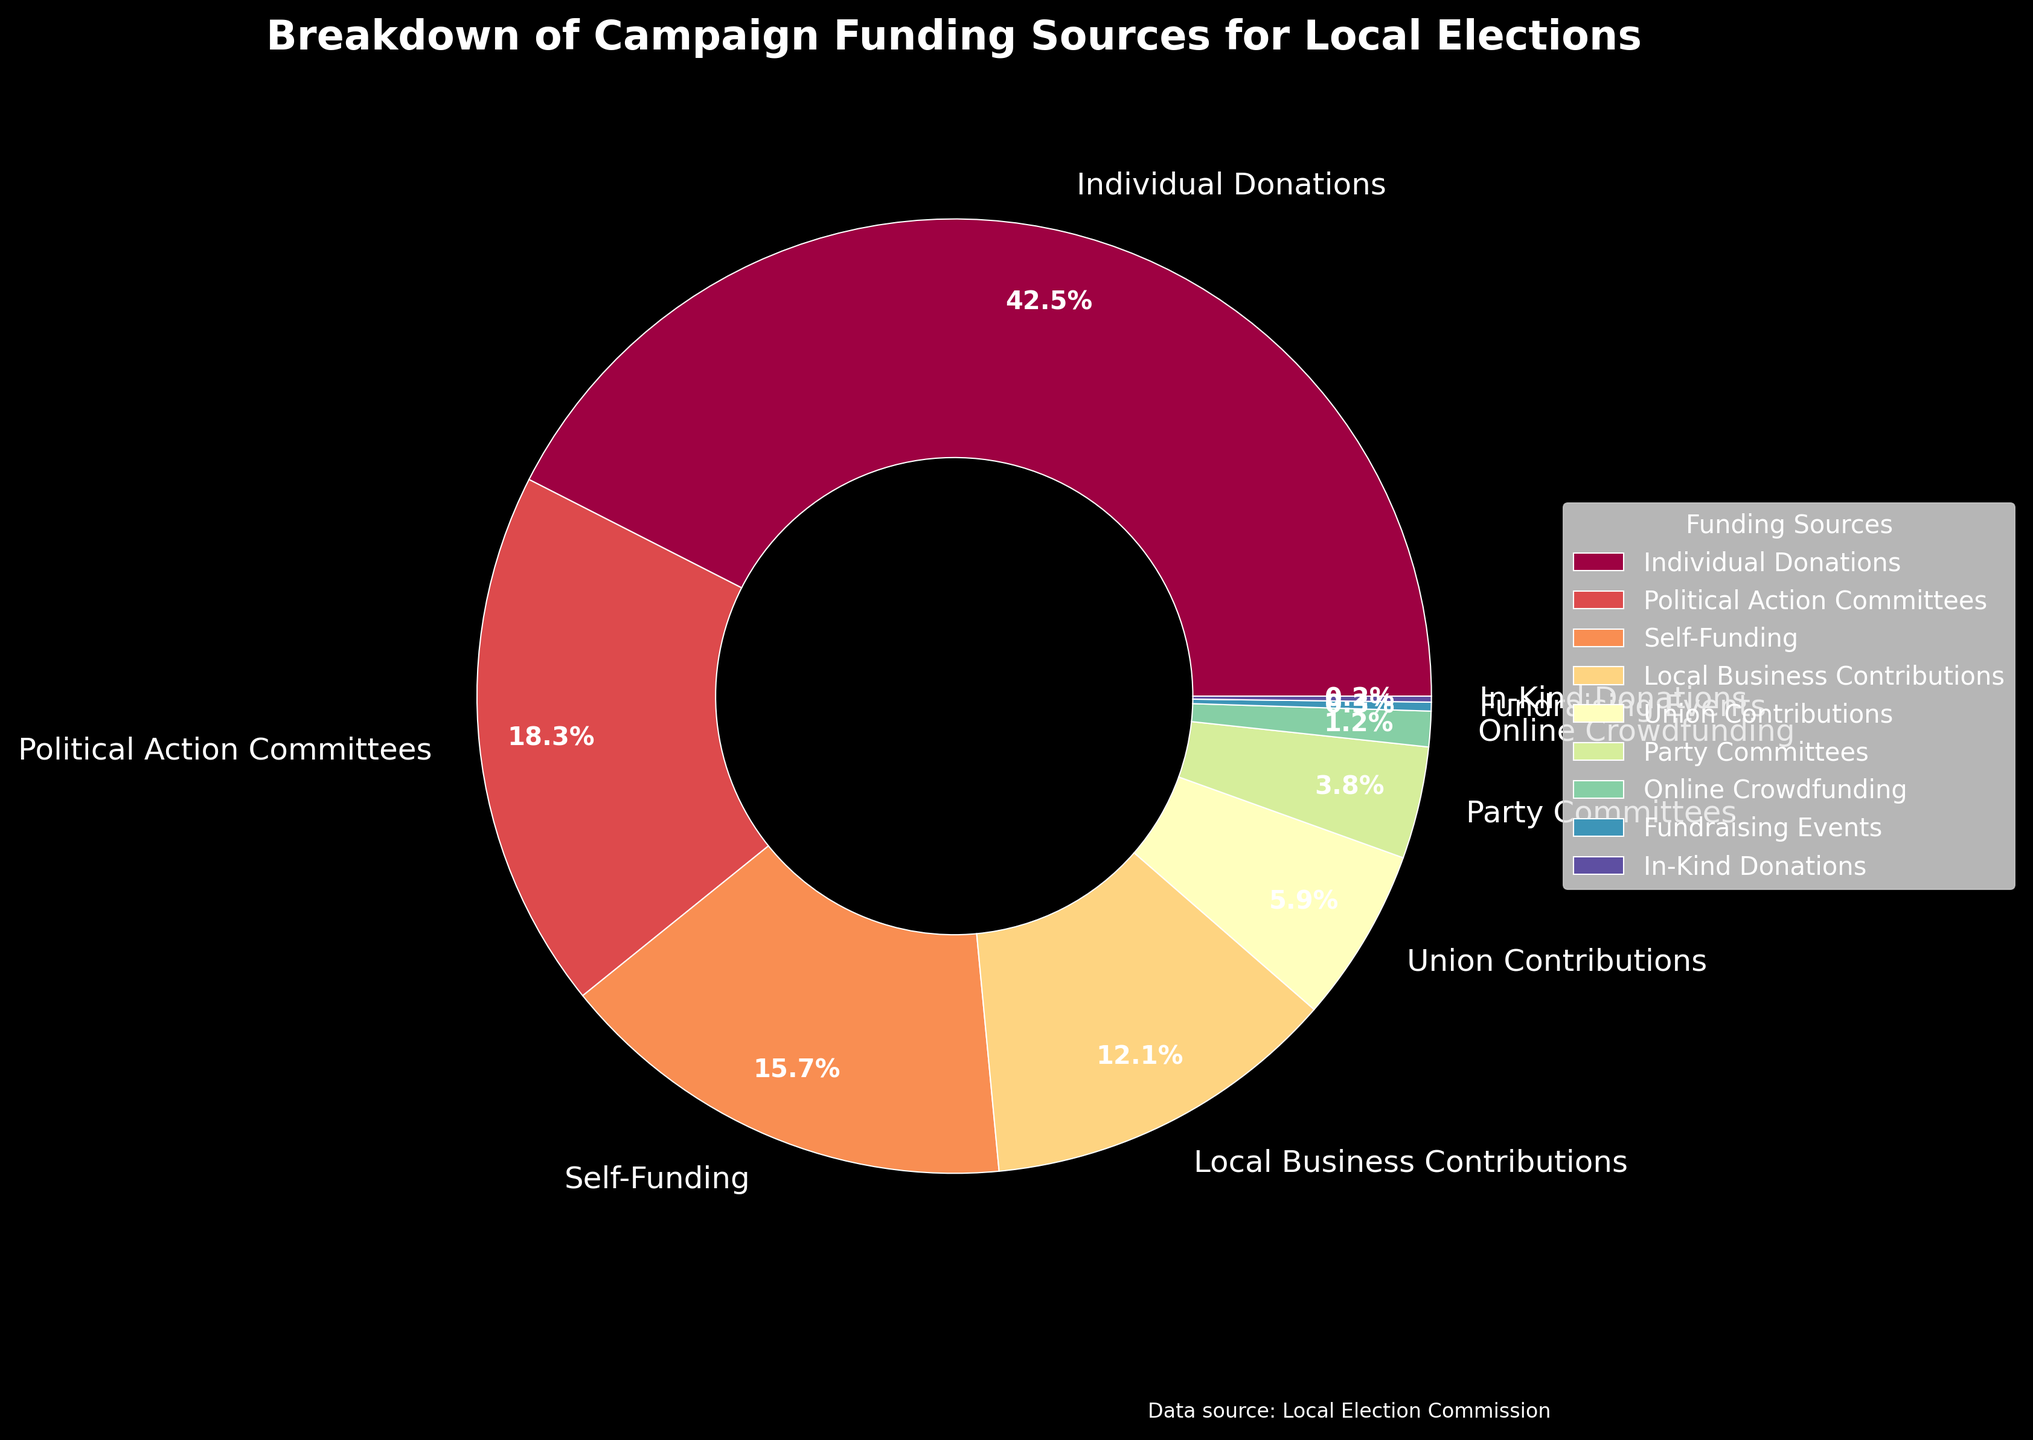What percentage of the total campaign funding comes from Individual Donations and Political Action Committees combined? To find the combined percentage, sum the percentages of Individual Donations and Political Action Committees. That is 42.5% + 18.3% = 60.8%.
Answer: 60.8% Which funding source contributes the least percentage to the campaign funding, and what is that percentage? To identify the funding source with the least contribution, look for the smallest percentage in the figure. In-Kind Donations has the smallest percentage of 0.2%.
Answer: In-Kind Donations, 0.2% Is the combined percentage of Self-Funding and Local Business Contributions greater than the percentage of Individual Donations? First, sum the percentages of Self-Funding and Local Business Contributions (15.7% + 12.1% = 27.8%). Then compare this sum to Individual Donations' percentage (42.5%). 27.8% is less than 42.5%.
Answer: No Rank the top three funding sources by their contribution percentages. By observing the figure, the top three funding sources are Individual Donations (42.5%), Political Action Committees (18.3%), and Self-Funding (15.7%).
Answer: Individual Donations, Political Action Committees, Self-Funding What is the difference in the contribution percentage between Union Contributions and Party Committees? Calculate the difference between the percentages of Union Contributions (5.9%) and Party Committees (3.8%). The difference is 5.9% - 3.8% = 2.1%.
Answer: 2.1% Are the contributions from Fundraising Events and In-Kind Donations equal? Compare the percentages of Fundraising Events (0.3%) and In-Kind Donations (0.2%). They are not equal.
Answer: No How much higher is the percentage of Individual Donations compared to Local Business Contributions? Subtract the percentage of Local Business Contributions (12.1%) from the percentage of Individual Donations (42.5%). The difference is 42.5% - 12.1% = 30.4%.
Answer: 30.4% Which funding sources have percentages less than 5%? Identify the funding sources from the figures with percentages less than 5%. These are Union Contributions (5.9% does not qualify), Party Committees (3.8%), Online Crowdfunding (1.2%), Fundraising Events (0.3%), and In-Kind Donations (0.2%).
Answer: Party Committees, Online Crowdfunding, Fundraising Events, In-Kind Donations Combine the contributions from Online Crowdfunding, Fundraising Events, and In-Kind Donations. What is their total percentage? Add the percentages of Online Crowdfunding (1.2%), Fundraising Events (0.3%), and In-Kind Donations (0.2%) together. The total percentage is 1.2% + 0.3% + 0.2% = 1.7%.
Answer: 1.7% 